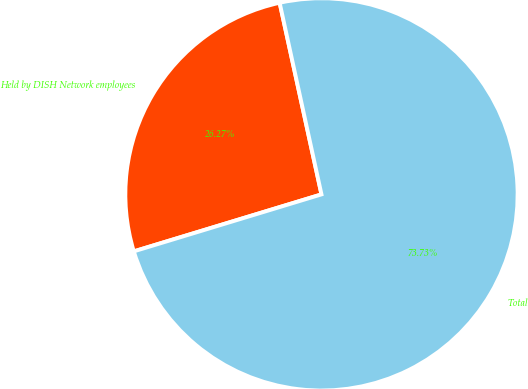Convert chart to OTSL. <chart><loc_0><loc_0><loc_500><loc_500><pie_chart><fcel>Held by DISH Network employees<fcel>Total<nl><fcel>26.27%<fcel>73.73%<nl></chart> 